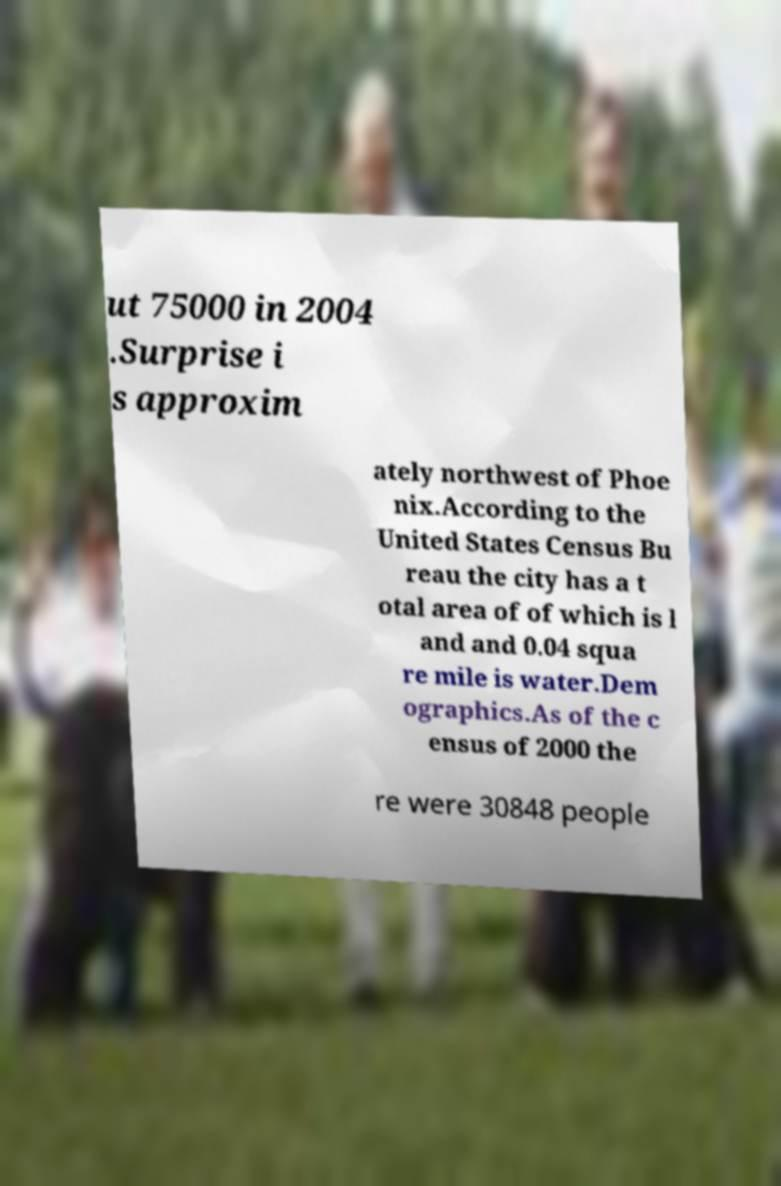For documentation purposes, I need the text within this image transcribed. Could you provide that? ut 75000 in 2004 .Surprise i s approxim ately northwest of Phoe nix.According to the United States Census Bu reau the city has a t otal area of of which is l and and 0.04 squa re mile is water.Dem ographics.As of the c ensus of 2000 the re were 30848 people 